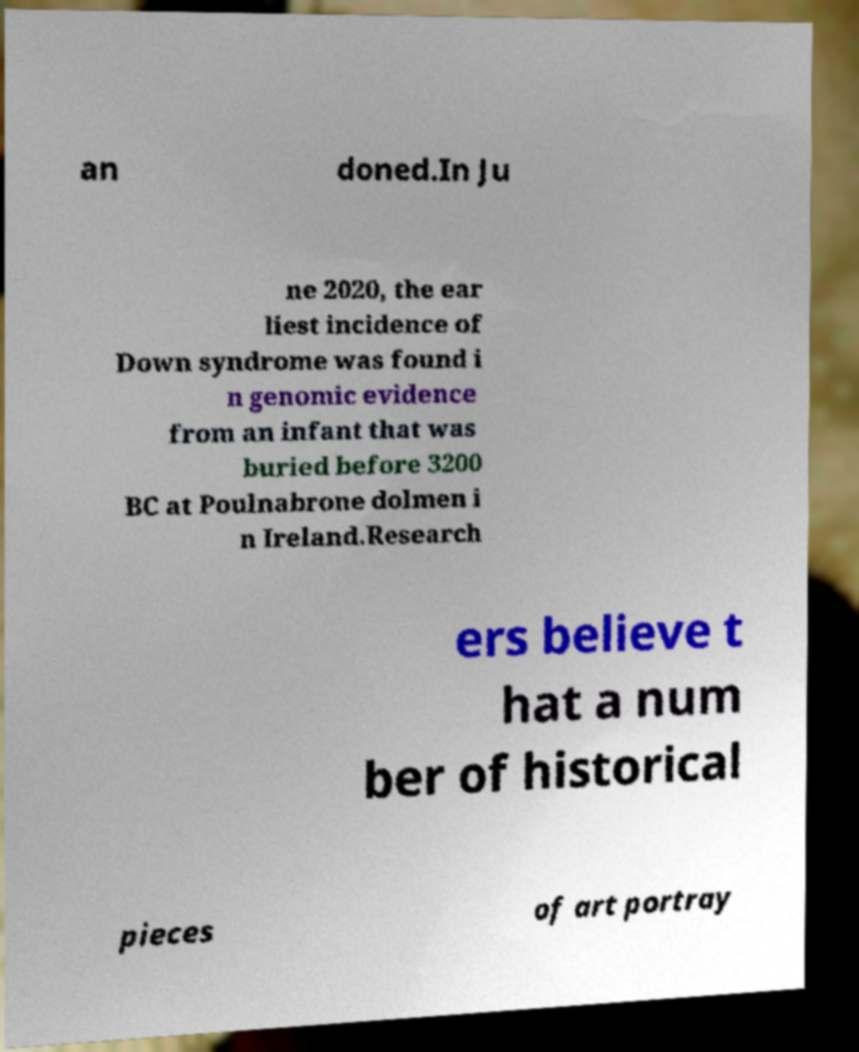What messages or text are displayed in this image? I need them in a readable, typed format. an doned.In Ju ne 2020, the ear liest incidence of Down syndrome was found i n genomic evidence from an infant that was buried before 3200 BC at Poulnabrone dolmen i n Ireland.Research ers believe t hat a num ber of historical pieces of art portray 